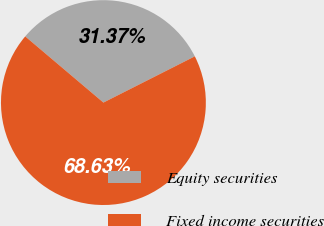Convert chart. <chart><loc_0><loc_0><loc_500><loc_500><pie_chart><fcel>Equity securities<fcel>Fixed income securities<nl><fcel>31.37%<fcel>68.63%<nl></chart> 